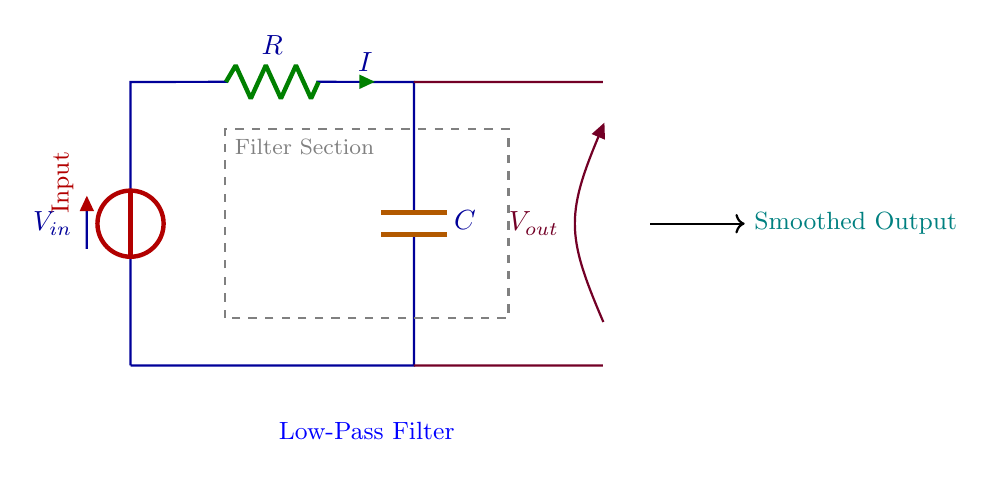What is the type of this circuit? The circuit is a low-pass filter designed to smooth out high-frequency noise from a power supply output. This is evidenced by the presence of a resistor and capacitor, which are essential components for filtering.
Answer: low-pass filter What is the input voltage of the circuit? The input voltage is denoted by the symbol V subscript in, which is labeled in red at the top of the circuit diagram.
Answer: V in What components are used in the filter section? The filter section contains a resistor and a capacitor. The resistor is labeled as R, and the capacitor is labeled as C, both situated in the filtering portion of the circuit.
Answer: resistor and capacitor What is indicated by the arrow on the right side of the circuit? The arrow at the right side indicates the output voltage, labeled as V subscript out. This shows where the smoothed voltage signal exits the filter circuit.
Answer: V out What is the role of the resistor in this circuit? The resistor acts to limit the current flow and works in conjunction with the capacitor to define the cut-off frequency of the filter, allowing low-frequency signals to pass while attenuating higher frequencies.
Answer: limit current What is the expected effect of this low-pass filter on the output signal? The low-pass filter smooths out the output signal by reducing high-frequency noise, allowing only lower frequency fluctuations through to the output, resulting in a cleaner and more stable output voltage.
Answer: smooth output Which color represents the capacitor in the circuit? The capacitor is represented in orange, clearly differentiating it from the other components in the diagram, which helps to identify its purpose in the filtering process.
Answer: orange 